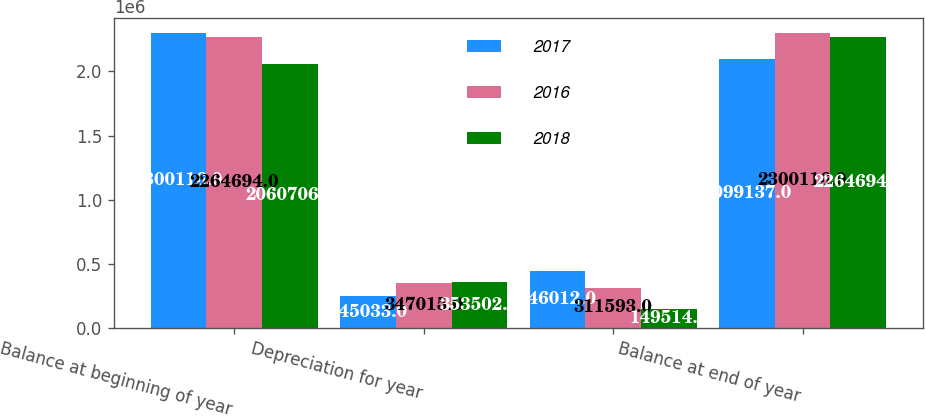<chart> <loc_0><loc_0><loc_500><loc_500><stacked_bar_chart><ecel><fcel>Balance at beginning of year<fcel>Depreciation for year<fcel>Unnamed: 3<fcel>Balance at end of year<nl><fcel>2017<fcel>2.30012e+06<fcel>245033<fcel>446012<fcel>2.09914e+06<nl><fcel>2016<fcel>2.26469e+06<fcel>347015<fcel>311593<fcel>2.30012e+06<nl><fcel>2018<fcel>2.06071e+06<fcel>353502<fcel>149514<fcel>2.26469e+06<nl></chart> 